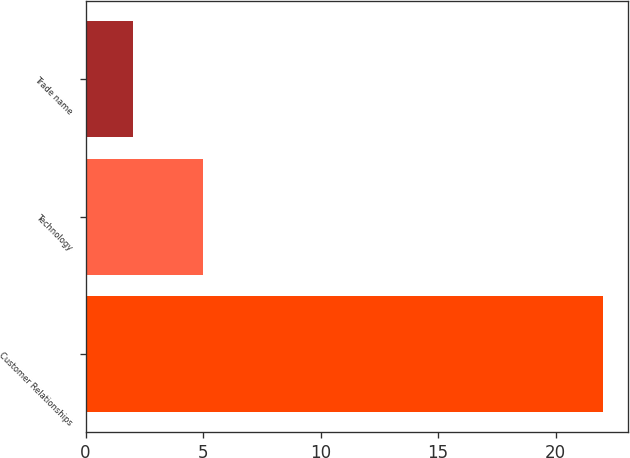Convert chart to OTSL. <chart><loc_0><loc_0><loc_500><loc_500><bar_chart><fcel>Customer Relationships<fcel>Technology<fcel>Trade name<nl><fcel>22<fcel>5<fcel>2<nl></chart> 